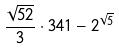<formula> <loc_0><loc_0><loc_500><loc_500>\frac { \sqrt { 5 2 } } { 3 } \cdot 3 4 1 - 2 ^ { \sqrt { 5 } }</formula> 